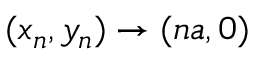Convert formula to latex. <formula><loc_0><loc_0><loc_500><loc_500>( x _ { n } , y _ { n } ) \rightarrow ( n a , 0 )</formula> 